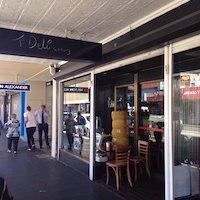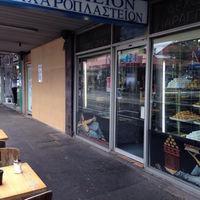The first image is the image on the left, the second image is the image on the right. Evaluate the accuracy of this statement regarding the images: "There is a female wearing her hair in a high bun next to some pastries.". Is it true? Answer yes or no. No. The first image is the image on the left, the second image is the image on the right. Given the left and right images, does the statement "A woman in white with her hair in a bun stands behind a counter in one image." hold true? Answer yes or no. No. 